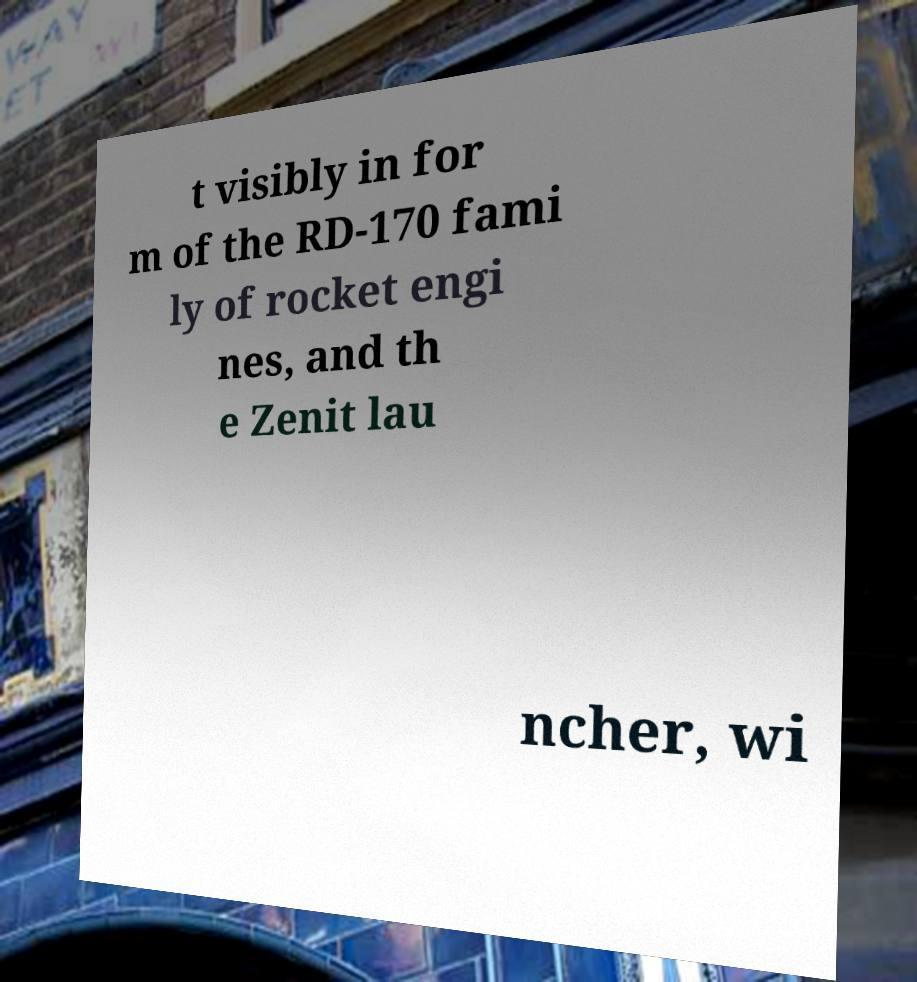For documentation purposes, I need the text within this image transcribed. Could you provide that? t visibly in for m of the RD-170 fami ly of rocket engi nes, and th e Zenit lau ncher, wi 